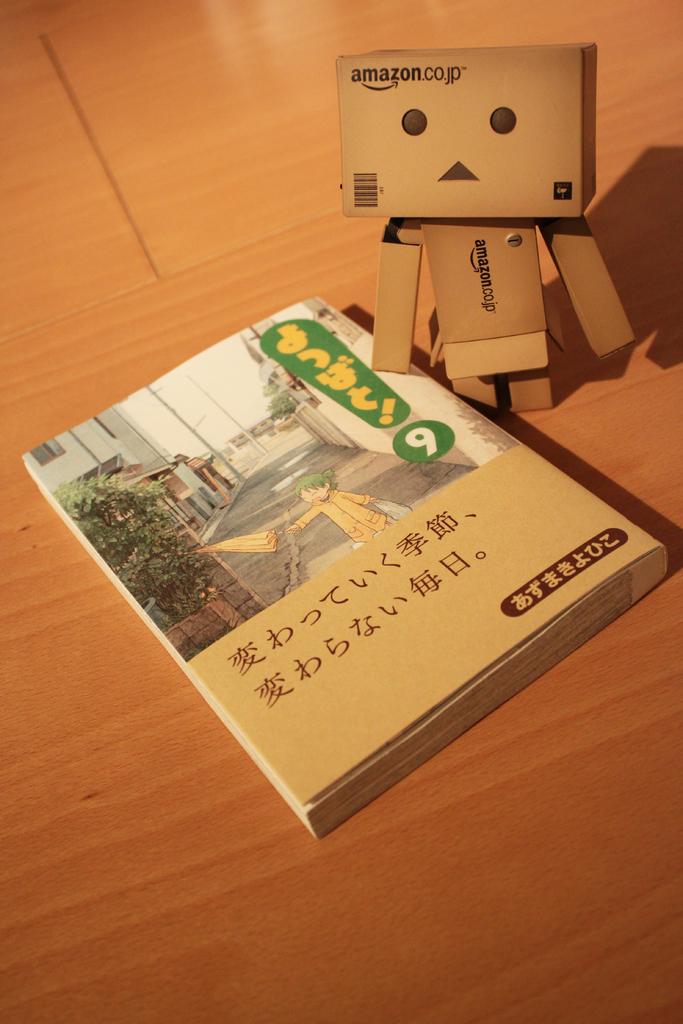Which company probably shipped this book?
Offer a terse response. Amazon. 